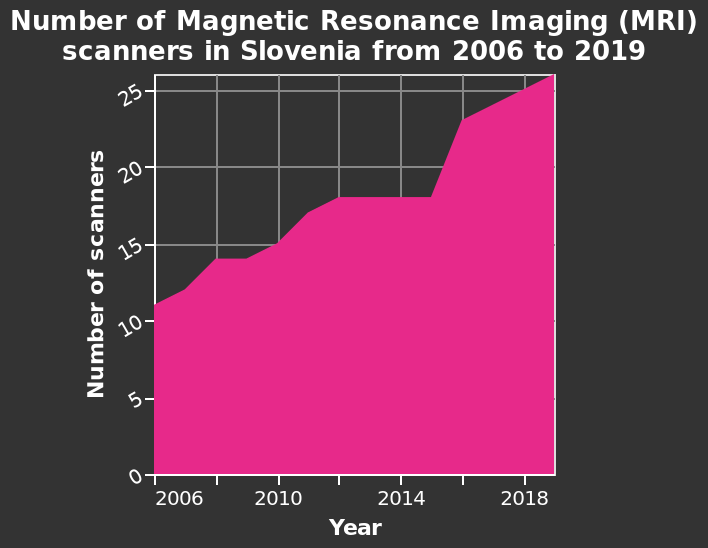<image>
What is the label of the x-axis in the area chart? The label of the x-axis is "Year". What was the total number of MRI scanners in Slovenia in 2019 after the period of stabilization? The total number of MRI scanners in Slovenia in 2019 was 26 after the period of stabilization. How many MRI scanners were there in Slovenia in 2019?  There were 26 MRI scanners in Slovenia in 2019. In which country is the area chart depicting the number of MRI scanners?  The area chart is depicting the number of MRI scanners in Slovenia. Were there 260 MRI scanners in Slovenia in 2019? No. There were 26 MRI scanners in Slovenia in 2019. 